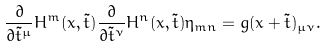Convert formula to latex. <formula><loc_0><loc_0><loc_500><loc_500>\frac { \partial } { \partial \tilde { t } ^ { \mu } } H ^ { m } ( x , \tilde { t } ) \frac { \partial } { \partial \tilde { t } ^ { \nu } } H ^ { n } ( x , \tilde { t } ) \eta _ { m n } = g ( x + \tilde { t } ) _ { \mu \nu } .</formula> 